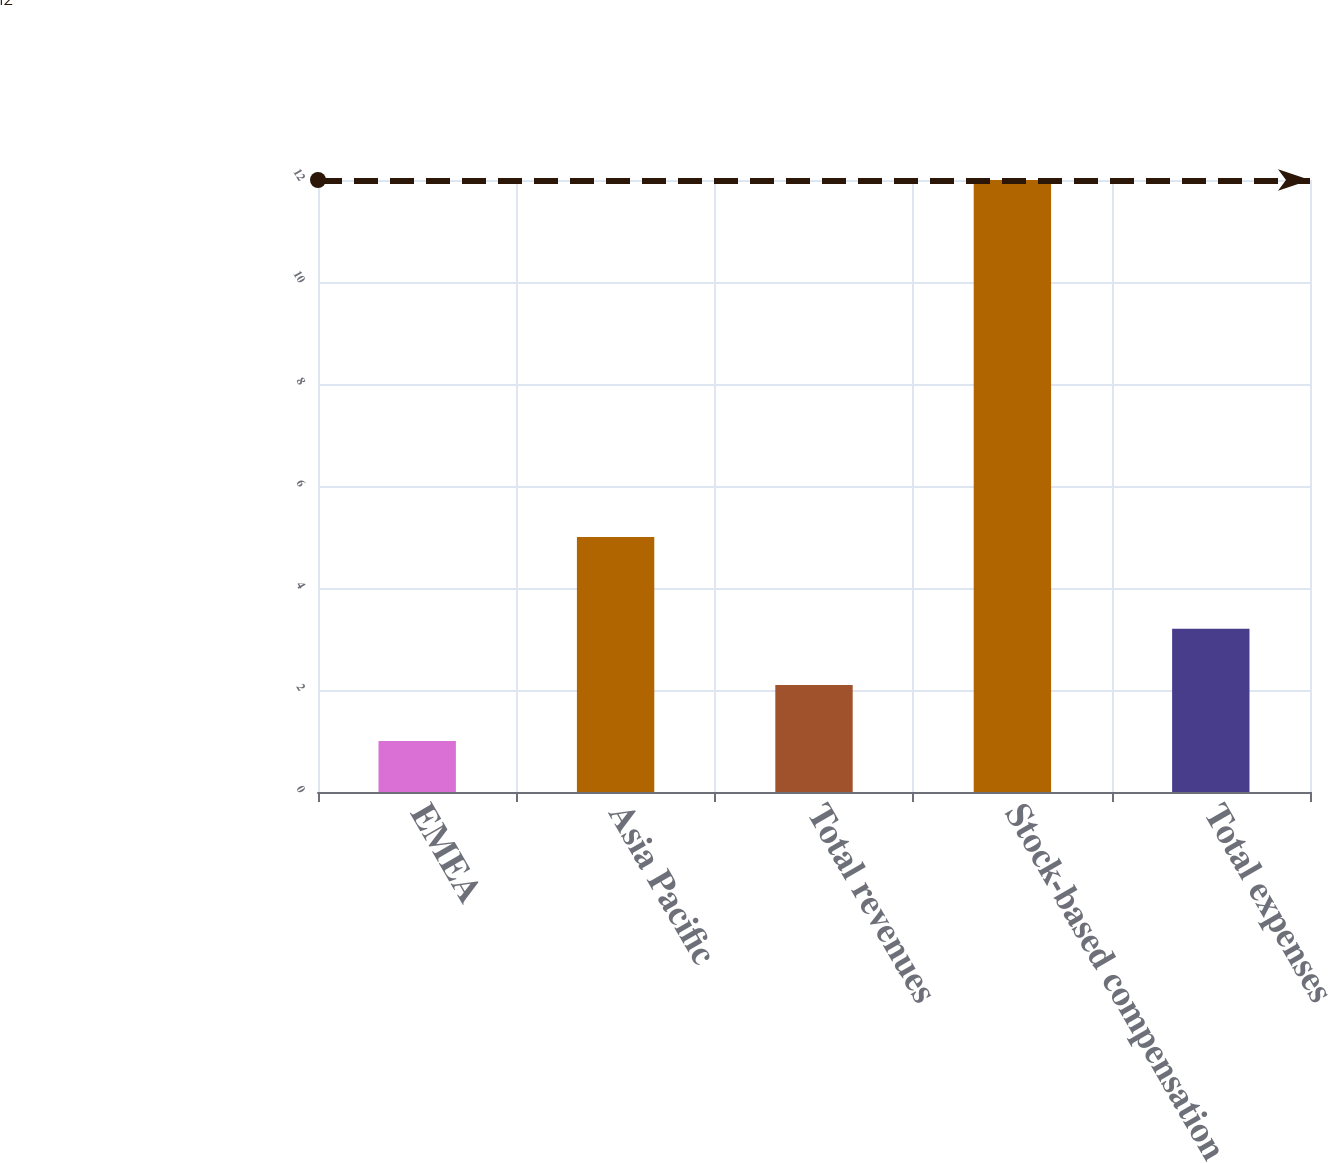Convert chart to OTSL. <chart><loc_0><loc_0><loc_500><loc_500><bar_chart><fcel>EMEA<fcel>Asia Pacific<fcel>Total revenues<fcel>Stock-based compensation<fcel>Total expenses<nl><fcel>1<fcel>5<fcel>2.1<fcel>12<fcel>3.2<nl></chart> 